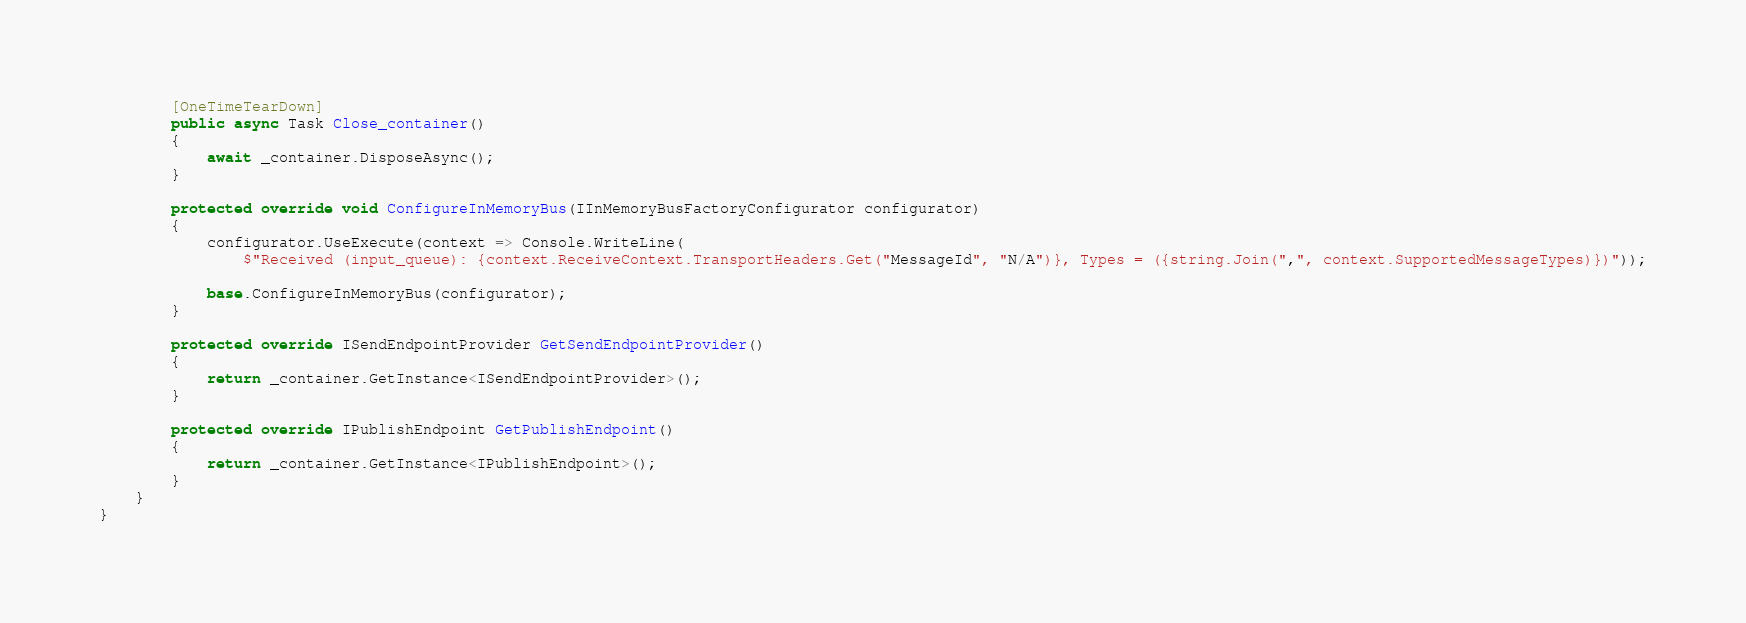<code> <loc_0><loc_0><loc_500><loc_500><_C#_>
        [OneTimeTearDown]
        public async Task Close_container()
        {
            await _container.DisposeAsync();
        }

        protected override void ConfigureInMemoryBus(IInMemoryBusFactoryConfigurator configurator)
        {
            configurator.UseExecute(context => Console.WriteLine(
                $"Received (input_queue): {context.ReceiveContext.TransportHeaders.Get("MessageId", "N/A")}, Types = ({string.Join(",", context.SupportedMessageTypes)})"));

            base.ConfigureInMemoryBus(configurator);
        }

        protected override ISendEndpointProvider GetSendEndpointProvider()
        {
            return _container.GetInstance<ISendEndpointProvider>();
        }

        protected override IPublishEndpoint GetPublishEndpoint()
        {
            return _container.GetInstance<IPublishEndpoint>();
        }
    }
}
</code> 